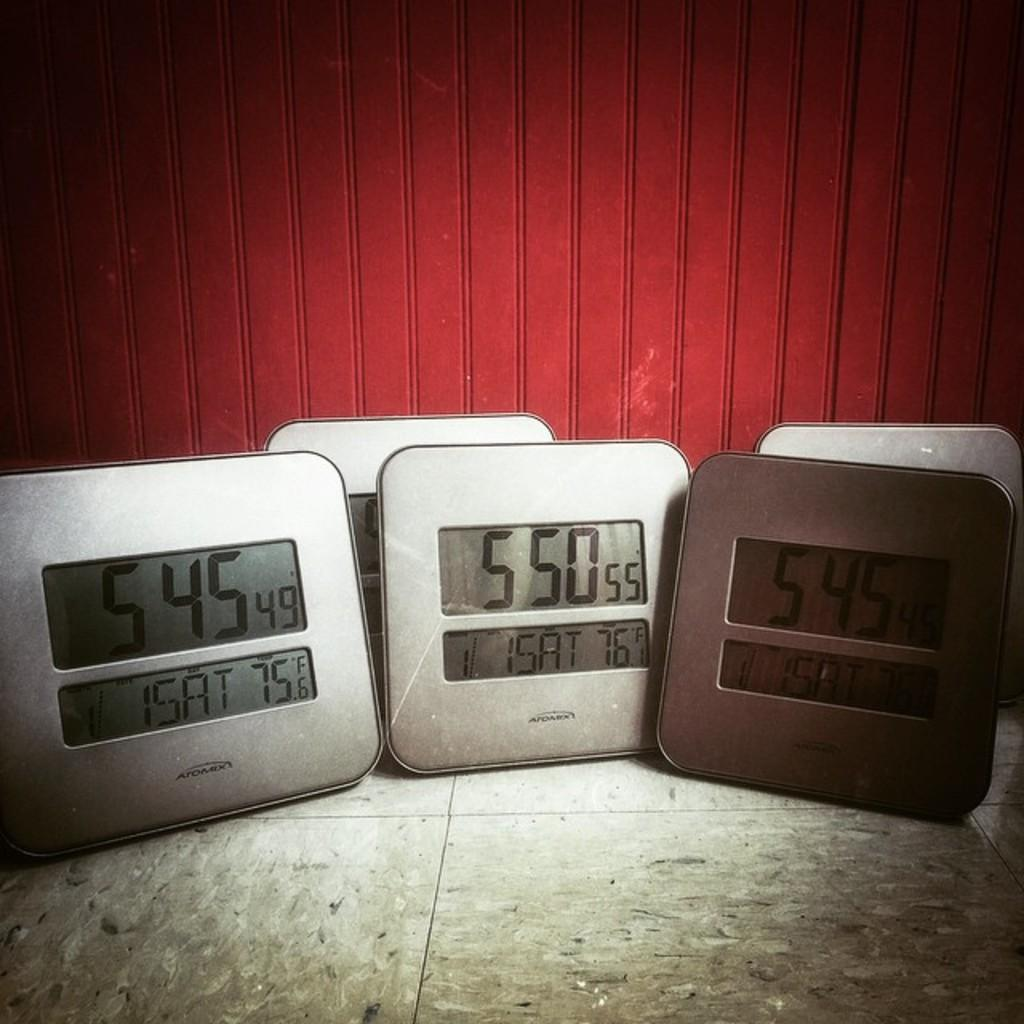<image>
Render a clear and concise summary of the photo. The clocks show two different times and to different temperatures in the the same room. 